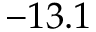Convert formula to latex. <formula><loc_0><loc_0><loc_500><loc_500>- 1 3 . 1</formula> 